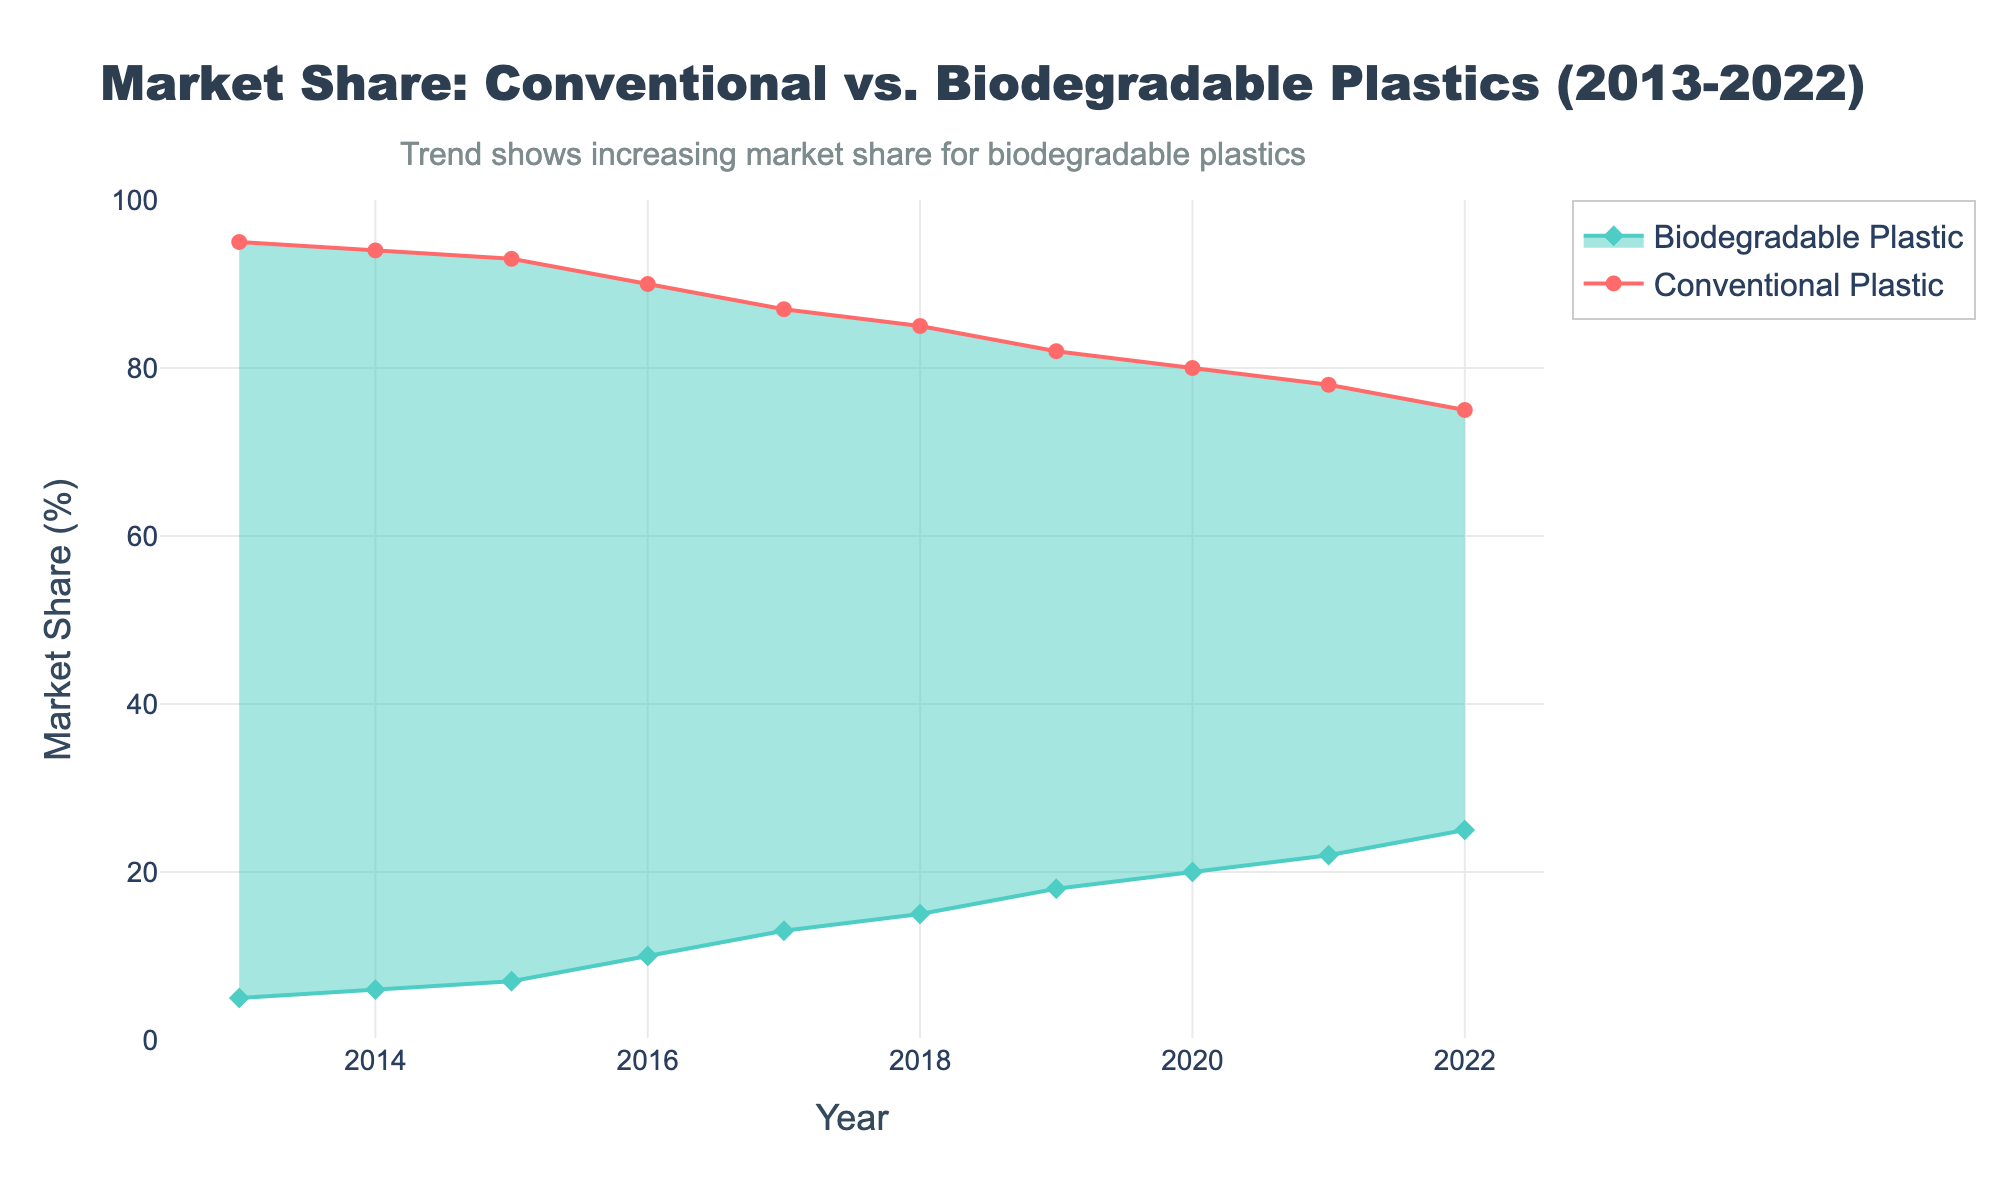Which year has the highest market share for conventional plastics? Looking at the graph, the year 2013 shows the highest market share for conventional plastics.
Answer: 2013 What is the range of market share between conventional and biodegradable plastics in 2019? The graph shows conventional plastic with 82% and biodegradable plastic with 18% market share in 2019. The range is calculated as 82% - 18% = 64%.
Answer: 64% Between which years did biodegradable plastics have the most significant increase in market share? Observing the graph, the most notable increase for biodegradable plastics happens between 2015 and 2016 when it rises from 7% to 10%.
Answer: 2015-2016 Compare the market share of conventional vs biodegradable plastics in 2022. In 2022, the market share for conventional plastics is 75% while it is 25% for biodegradable plastics, showing that conventional plastics hold a higher share.
Answer: Conventional: 75%, Biodegradable: 25% How does the total market share (sum of both types) change over the decade? Throughout the decade, the total market share is always constant at 100% for both conventional and biodegradable plastics combined.
Answer: 100% What is the average annual decrease in market share for conventional plastics over the decade? Calculate by finding the difference in market share from 2013 to 2022 (95% - 75% = 20%) and then divide by the number of years (2013-2022=10 years). So, 20% / 10 = 2% per year.
Answer: 2% per year Identify the year where the market share for biodegradable plastics first reached double digits. The graph displays that biodegradable plastics first hit 10% in the year 2016.
Answer: 2016 In which year do biodegradable plastics reach a market share of 20%? From the graph, it is clear that biodegradable plastics reach a 20% market share in the year 2020.
Answer: 2020 By how much did the market share for conventional plastics drop from 2013 to 2022? Subtract the market share of conventional plastics in 2022 (75%) from that in 2013 (95%), resulting in a drop of 20%.
Answer: 20% Describe the trend in biodegradable plastics market share from 2013 to 2022. The chart shows a consistent upward trend in the market share of biodegradable plastics, starting at 5% in 2013 and rising to 25% by 2022.
Answer: Increasing trend 